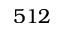Convert formula to latex. <formula><loc_0><loc_0><loc_500><loc_500>5 1 2</formula> 